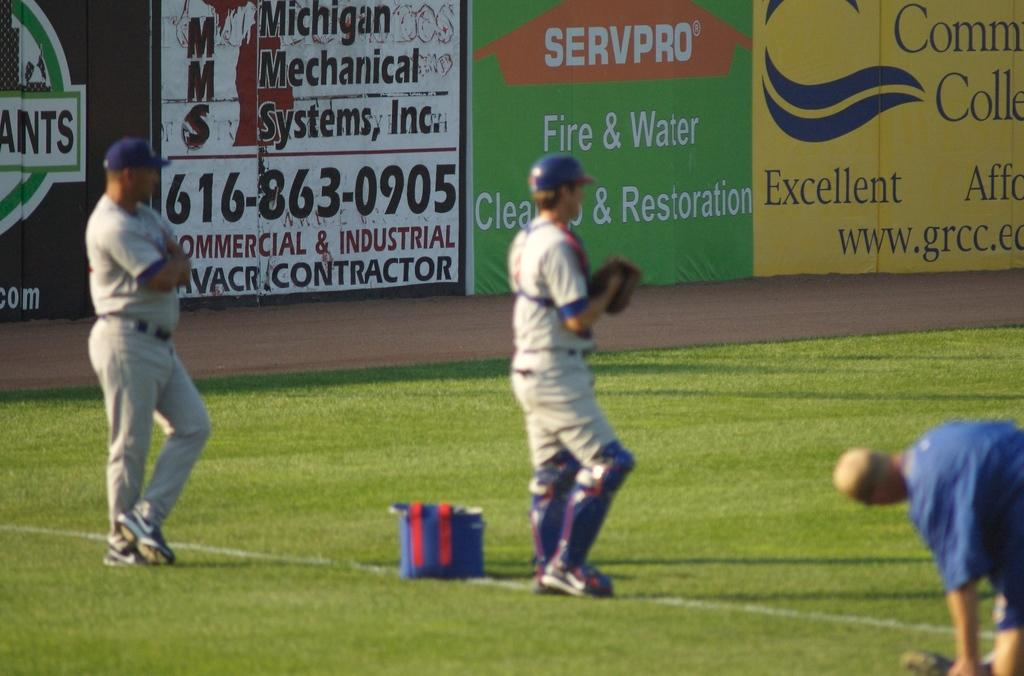<image>
Give a short and clear explanation of the subsequent image. baseball game with sponsors servpro and michigan mechanical systems 